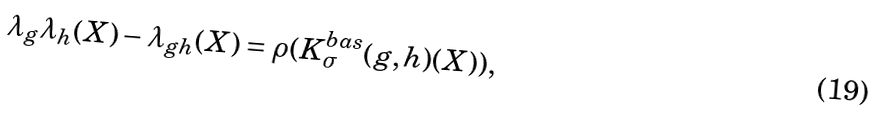<formula> <loc_0><loc_0><loc_500><loc_500>\lambda _ { g } \lambda _ { h } ( X ) - \lambda _ { g h } ( X ) = \rho ( K ^ { b a s } _ { \sigma } ( g , h ) ( X ) ) ,</formula> 